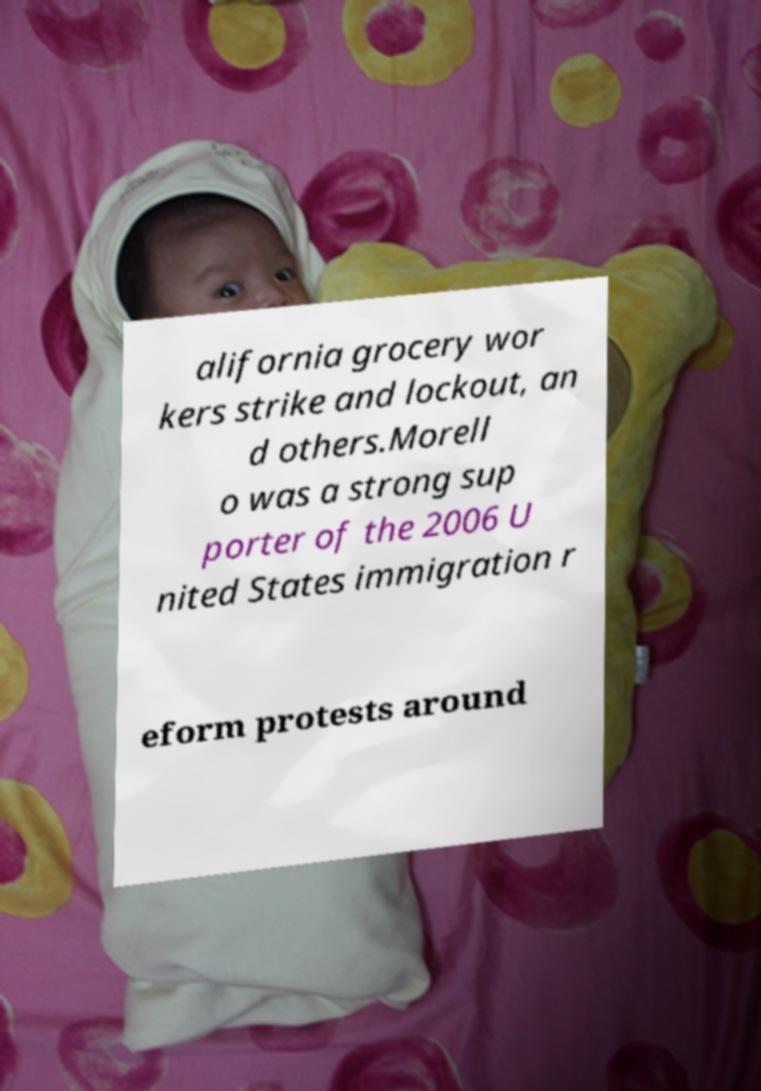Could you extract and type out the text from this image? alifornia grocery wor kers strike and lockout, an d others.Morell o was a strong sup porter of the 2006 U nited States immigration r eform protests around 